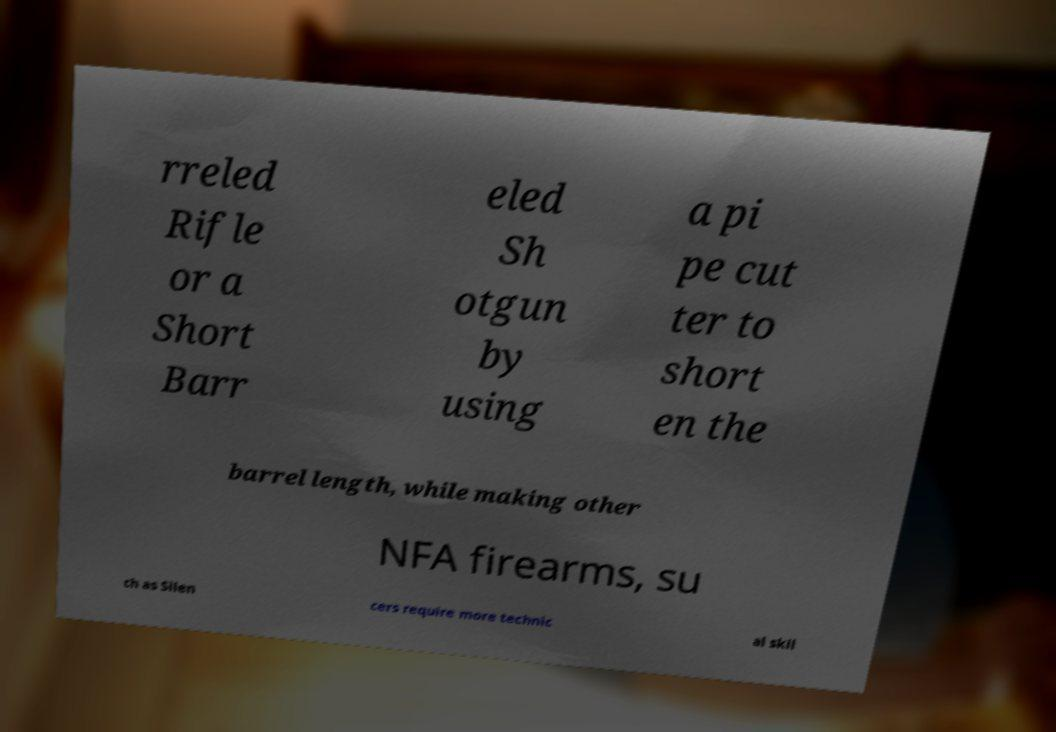Can you accurately transcribe the text from the provided image for me? rreled Rifle or a Short Barr eled Sh otgun by using a pi pe cut ter to short en the barrel length, while making other NFA firearms, su ch as Silen cers require more technic al skil 